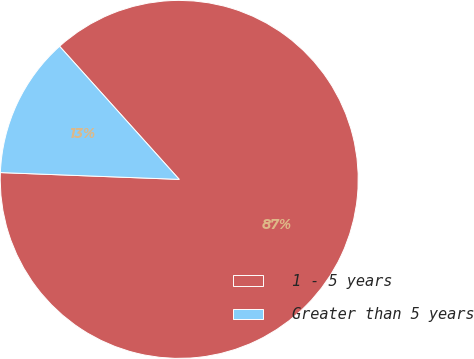Convert chart. <chart><loc_0><loc_0><loc_500><loc_500><pie_chart><fcel>1 - 5 years<fcel>Greater than 5 years<nl><fcel>87.26%<fcel>12.74%<nl></chart> 